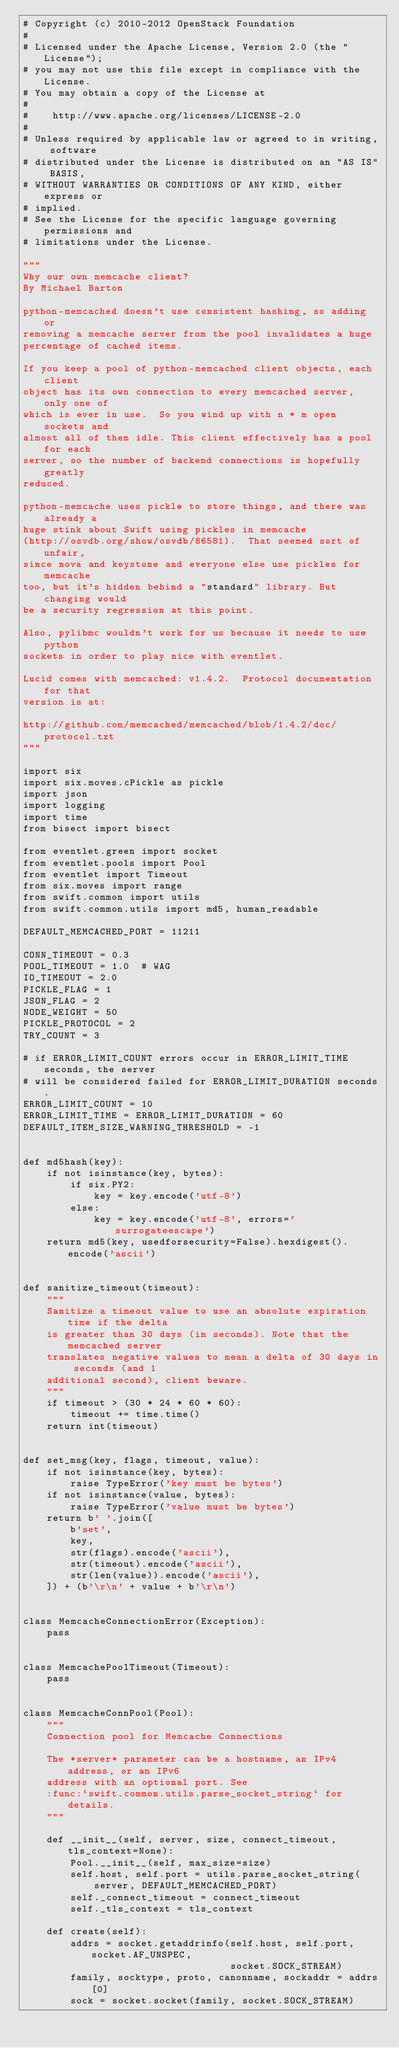Convert code to text. <code><loc_0><loc_0><loc_500><loc_500><_Python_># Copyright (c) 2010-2012 OpenStack Foundation
#
# Licensed under the Apache License, Version 2.0 (the "License");
# you may not use this file except in compliance with the License.
# You may obtain a copy of the License at
#
#    http://www.apache.org/licenses/LICENSE-2.0
#
# Unless required by applicable law or agreed to in writing, software
# distributed under the License is distributed on an "AS IS" BASIS,
# WITHOUT WARRANTIES OR CONDITIONS OF ANY KIND, either express or
# implied.
# See the License for the specific language governing permissions and
# limitations under the License.

"""
Why our own memcache client?
By Michael Barton

python-memcached doesn't use consistent hashing, so adding or
removing a memcache server from the pool invalidates a huge
percentage of cached items.

If you keep a pool of python-memcached client objects, each client
object has its own connection to every memcached server, only one of
which is ever in use.  So you wind up with n * m open sockets and
almost all of them idle. This client effectively has a pool for each
server, so the number of backend connections is hopefully greatly
reduced.

python-memcache uses pickle to store things, and there was already a
huge stink about Swift using pickles in memcache
(http://osvdb.org/show/osvdb/86581).  That seemed sort of unfair,
since nova and keystone and everyone else use pickles for memcache
too, but it's hidden behind a "standard" library. But changing would
be a security regression at this point.

Also, pylibmc wouldn't work for us because it needs to use python
sockets in order to play nice with eventlet.

Lucid comes with memcached: v1.4.2.  Protocol documentation for that
version is at:

http://github.com/memcached/memcached/blob/1.4.2/doc/protocol.txt
"""

import six
import six.moves.cPickle as pickle
import json
import logging
import time
from bisect import bisect

from eventlet.green import socket
from eventlet.pools import Pool
from eventlet import Timeout
from six.moves import range
from swift.common import utils
from swift.common.utils import md5, human_readable

DEFAULT_MEMCACHED_PORT = 11211

CONN_TIMEOUT = 0.3
POOL_TIMEOUT = 1.0  # WAG
IO_TIMEOUT = 2.0
PICKLE_FLAG = 1
JSON_FLAG = 2
NODE_WEIGHT = 50
PICKLE_PROTOCOL = 2
TRY_COUNT = 3

# if ERROR_LIMIT_COUNT errors occur in ERROR_LIMIT_TIME seconds, the server
# will be considered failed for ERROR_LIMIT_DURATION seconds.
ERROR_LIMIT_COUNT = 10
ERROR_LIMIT_TIME = ERROR_LIMIT_DURATION = 60
DEFAULT_ITEM_SIZE_WARNING_THRESHOLD = -1


def md5hash(key):
    if not isinstance(key, bytes):
        if six.PY2:
            key = key.encode('utf-8')
        else:
            key = key.encode('utf-8', errors='surrogateescape')
    return md5(key, usedforsecurity=False).hexdigest().encode('ascii')


def sanitize_timeout(timeout):
    """
    Sanitize a timeout value to use an absolute expiration time if the delta
    is greater than 30 days (in seconds). Note that the memcached server
    translates negative values to mean a delta of 30 days in seconds (and 1
    additional second), client beware.
    """
    if timeout > (30 * 24 * 60 * 60):
        timeout += time.time()
    return int(timeout)


def set_msg(key, flags, timeout, value):
    if not isinstance(key, bytes):
        raise TypeError('key must be bytes')
    if not isinstance(value, bytes):
        raise TypeError('value must be bytes')
    return b' '.join([
        b'set',
        key,
        str(flags).encode('ascii'),
        str(timeout).encode('ascii'),
        str(len(value)).encode('ascii'),
    ]) + (b'\r\n' + value + b'\r\n')


class MemcacheConnectionError(Exception):
    pass


class MemcachePoolTimeout(Timeout):
    pass


class MemcacheConnPool(Pool):
    """
    Connection pool for Memcache Connections

    The *server* parameter can be a hostname, an IPv4 address, or an IPv6
    address with an optional port. See
    :func:`swift.common.utils.parse_socket_string` for details.
    """

    def __init__(self, server, size, connect_timeout, tls_context=None):
        Pool.__init__(self, max_size=size)
        self.host, self.port = utils.parse_socket_string(
            server, DEFAULT_MEMCACHED_PORT)
        self._connect_timeout = connect_timeout
        self._tls_context = tls_context

    def create(self):
        addrs = socket.getaddrinfo(self.host, self.port, socket.AF_UNSPEC,
                                   socket.SOCK_STREAM)
        family, socktype, proto, canonname, sockaddr = addrs[0]
        sock = socket.socket(family, socket.SOCK_STREAM)</code> 